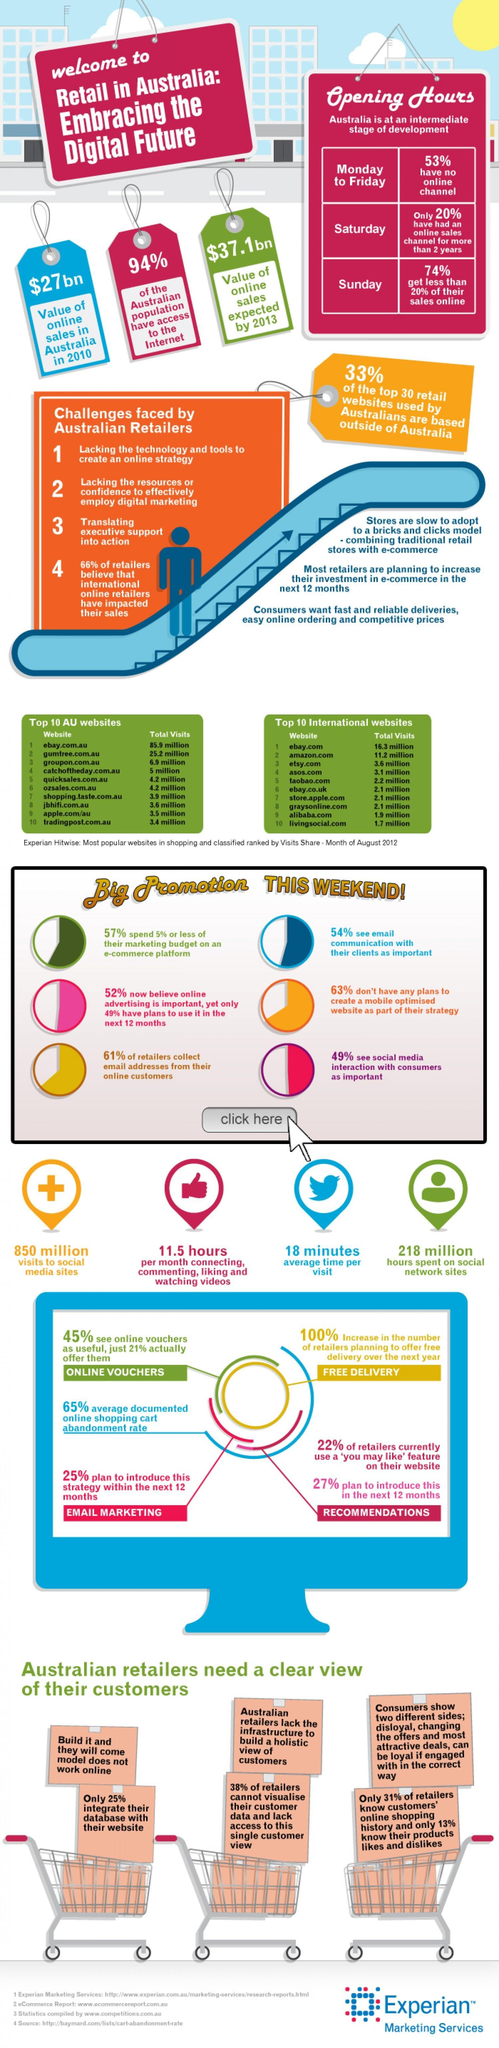What percentage of the top 30 retail websites used by Australians are based outside of Australia?
Answer the question with a short phrase. 33% What percentage of retailers collect email addresses from their online customers? 61% Which is the least visited international website? livingsocial.com What percentage of the Australian population have access to the internet? 94% What is the total visits recorded for the website 'ozsales.com.au'? 4.2 million Which is the top viewed Australian website? ebay.com.au What is the value of online sales expected in Australia by 2013? $37.1 bn 